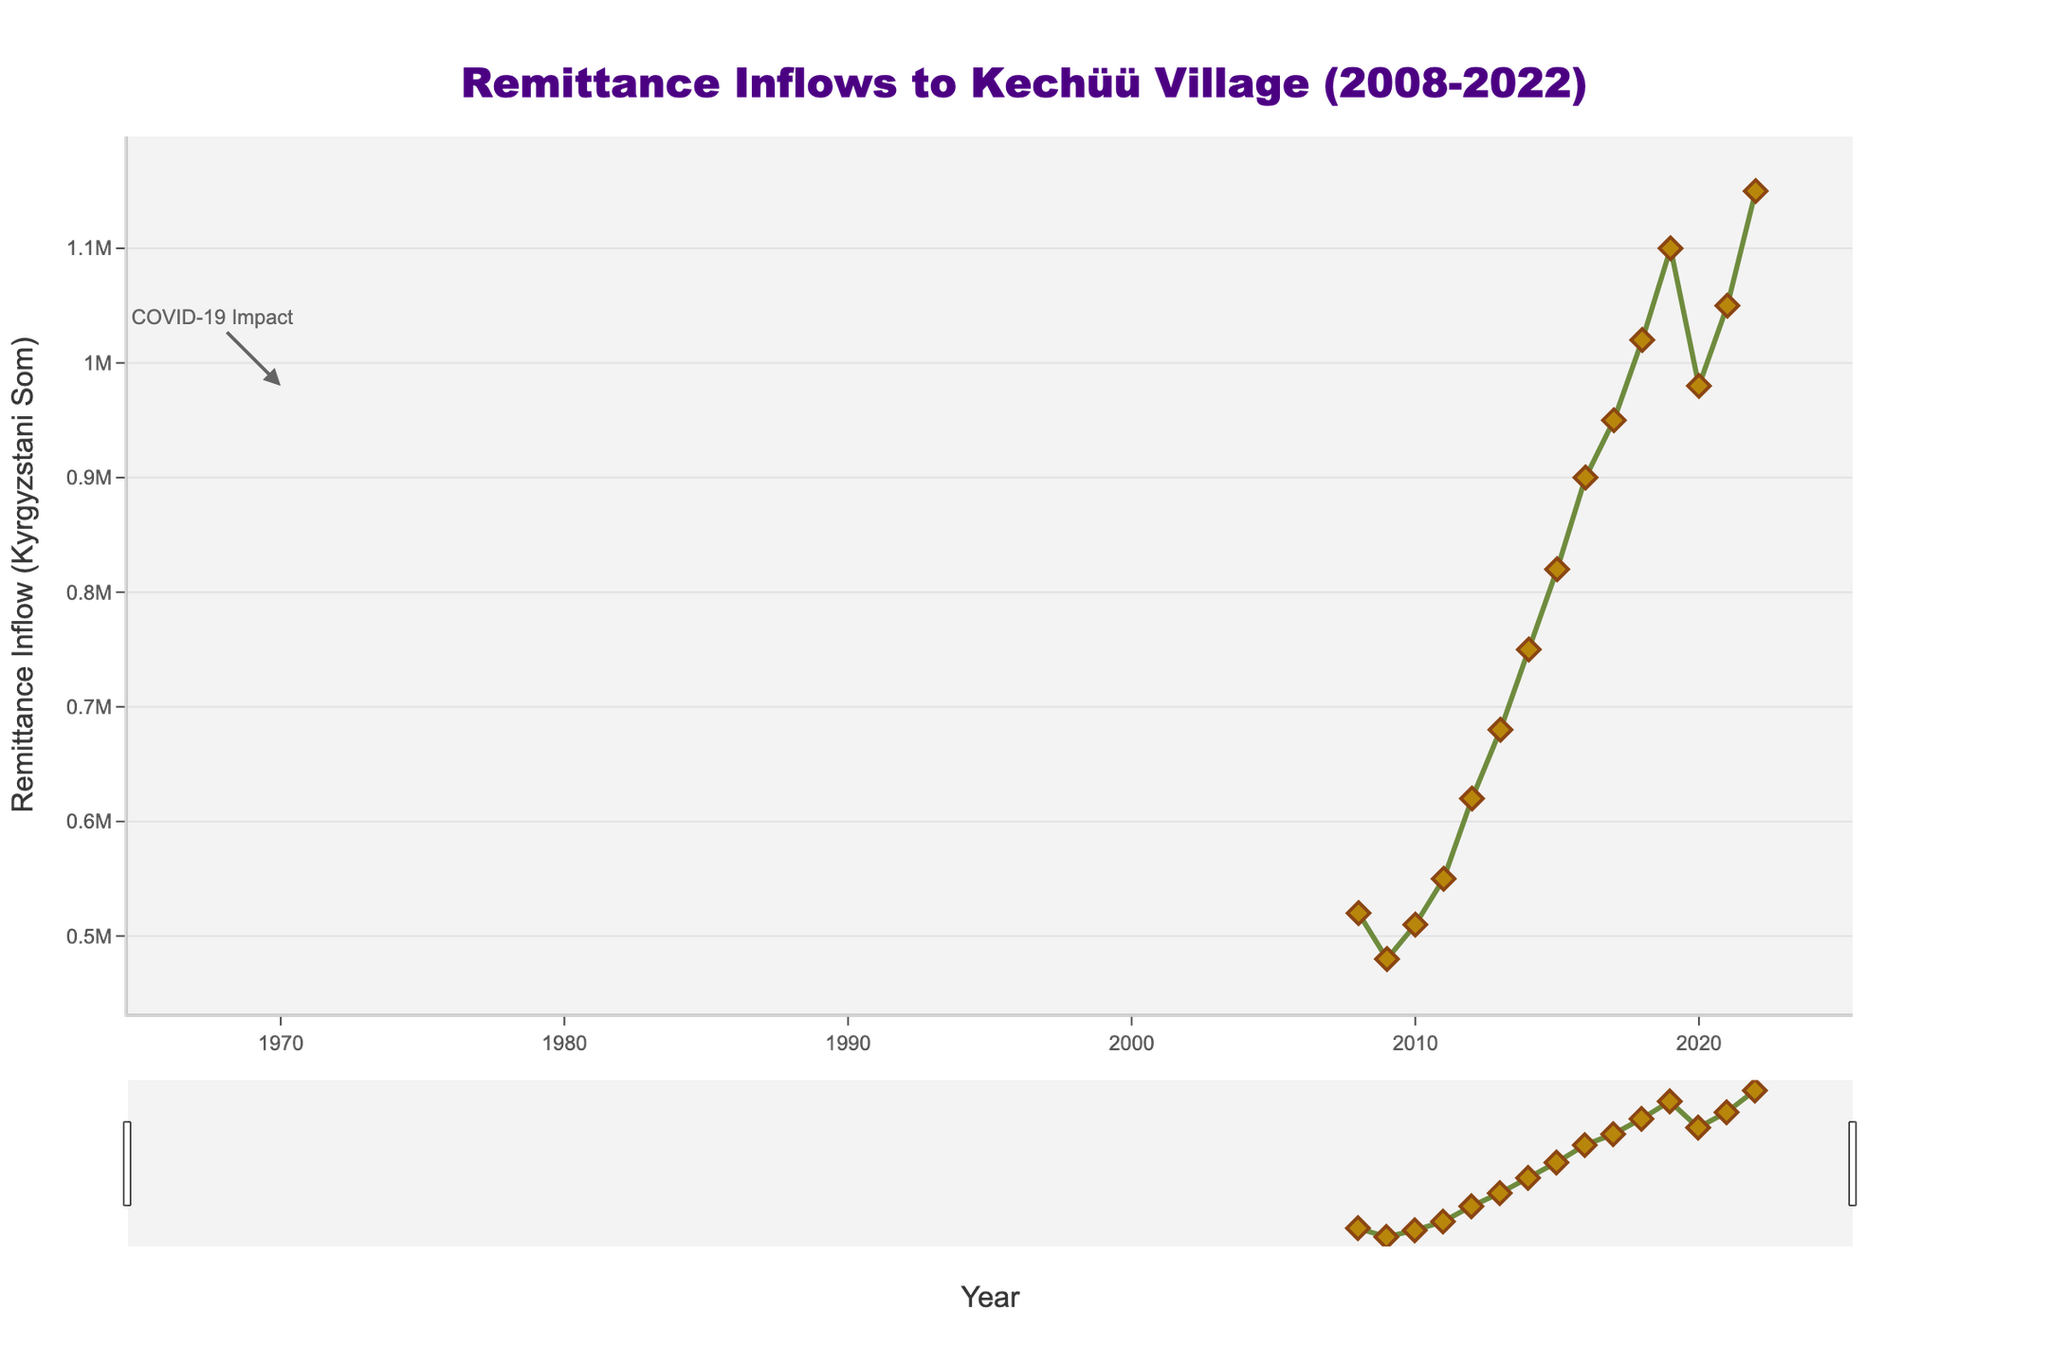What was the remittance inflow in the year 2010 compared to 2022? To find this answer, look at the data points for the years 2010 and 2022. In 2010, the remittance inflow was 510,000 Som, and in 2022, it was 1,150,000 Som.
Answer: The inflow increased from 510,000 Som to 1,150,000 Som How much did the remittance inflow decrease in 2020 compared to 2019? The remittance inflow in 2019 was 1,100,000 Som, and in 2020 it was 980,000 Som. Subtract 980,000 from 1,100,000 to find the decrease.
Answer: The inflow decreased by 120,000 Som What is the overall trend in remittance inflow from 2008 to 2022? Observing the chart, the overall trend shows an increase over the years, with a slight dip in 2020.
Answer: The overall trend is increasing Compare the remittance inflow in 2011 and 2014. Which year had a higher inflow and by how much? The remittance inflow in 2011 was 550,000 Som, and in 2014 it was 750,000 Som. Subtract 550,000 from 750,000 to find the difference.
Answer: 2014 had a higher inflow by 200,000 Som What year experienced the highest sudden increase in remittance inflow? To determine this, calculate the year-over-year differences and find the largest increase. The biggest jump appears to be between 2018 and 2019.
Answer: The highest increase was in 2019 What was the average remittance inflow from 2008 to 2012? Sum the inflows from 2008 (520,000 Som) to 2012 (620,000 Som) and divide by the number of years (5). (520,000 + 480,000 + 510,000 + 550,000 + 620,000) / 5 = 2,680,000 / 5 = 536,000 Som.
Answer: 536,000 Som What visual element represents the importance of the year 2020 in the graph? There is an annotation in the form of a text "COVID-19 Impact" with an arrow pointing to the dip in 2020.
Answer: The annotation "COVID-19 Impact" with an arrow Which year had the lowest remittance inflow, and what was the amount? By examining the chart, the lowest remittance inflow was in 2009 with 480,000 Som.
Answer: 2009 with 480,000 Som 